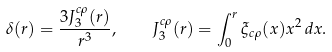<formula> <loc_0><loc_0><loc_500><loc_500>\delta ( r ) = \frac { 3 J ^ { c \rho } _ { 3 } ( r ) } { r ^ { 3 } } , \quad J ^ { c \rho } _ { 3 } ( r ) = \int _ { 0 } ^ { r } \xi _ { c \rho } ( x ) x ^ { 2 } \, d x .</formula> 